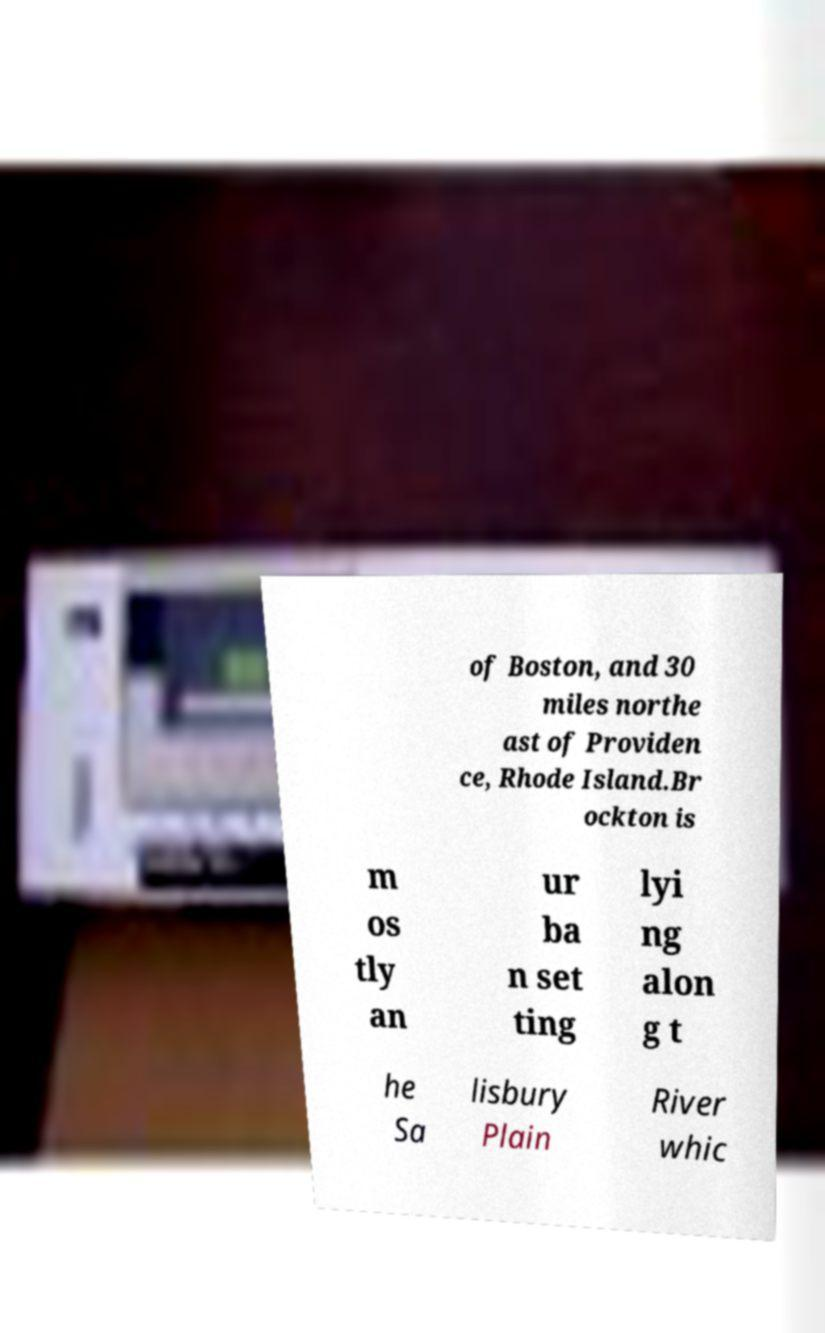Please read and relay the text visible in this image. What does it say? of Boston, and 30 miles northe ast of Providen ce, Rhode Island.Br ockton is m os tly an ur ba n set ting lyi ng alon g t he Sa lisbury Plain River whic 